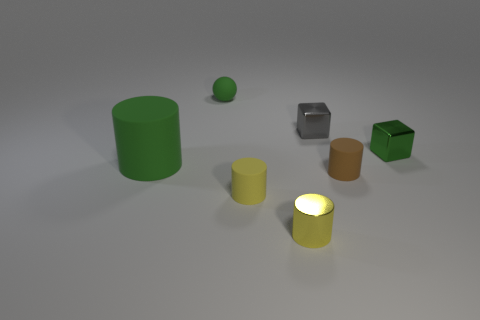Are there any other things that are the same size as the green cylinder?
Your response must be concise. No. There is a big green thing that is made of the same material as the sphere; what shape is it?
Offer a very short reply. Cylinder. Are there any green metal things on the left side of the brown thing?
Your response must be concise. No. Is the number of tiny shiny cubes that are to the left of the green metallic cube less than the number of cyan cubes?
Give a very brief answer. No. What is the material of the ball?
Offer a terse response. Rubber. What is the color of the big rubber object?
Your answer should be compact. Green. What color is the tiny object that is both to the right of the yellow metal object and in front of the large rubber cylinder?
Ensure brevity in your answer.  Brown. Is the material of the tiny green sphere the same as the green object that is in front of the green block?
Make the answer very short. Yes. There is a metallic thing in front of the matte cylinder that is behind the tiny brown thing; what is its size?
Offer a terse response. Small. Is there anything else that is the same color as the small metallic cylinder?
Ensure brevity in your answer.  Yes. 